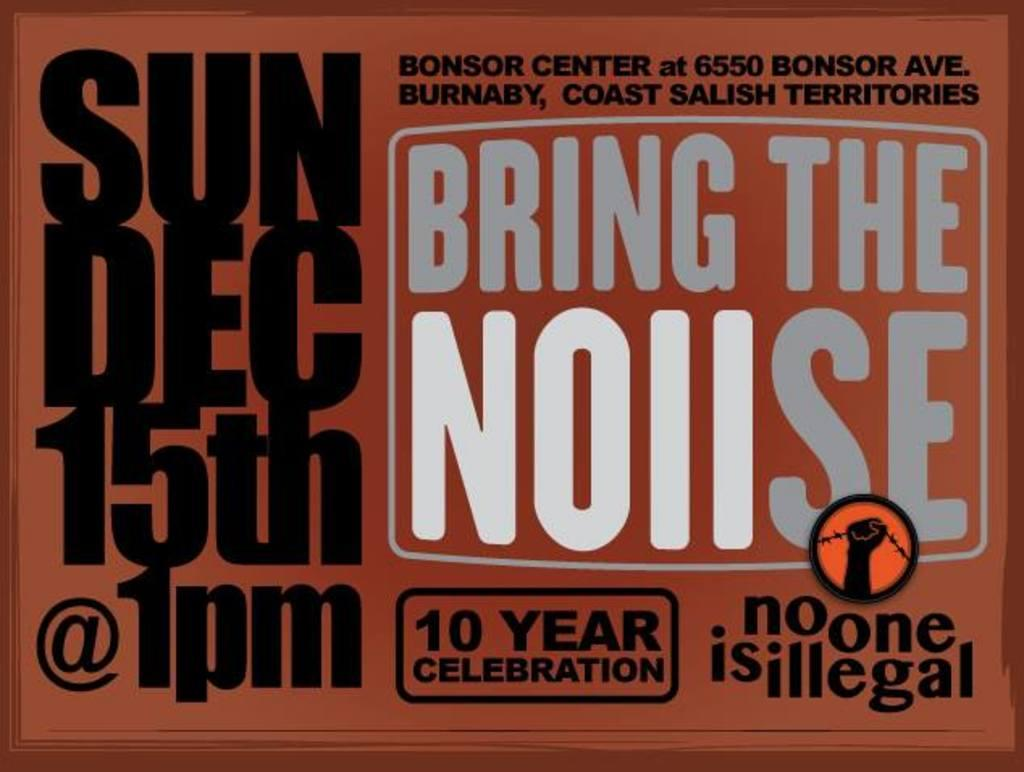<image>
Present a compact description of the photo's key features. An ad for Bring the Noiise says it's a 10 year celebration. 